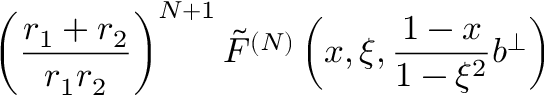<formula> <loc_0><loc_0><loc_500><loc_500>\left ( \frac { r _ { 1 } + r _ { 2 } } { r _ { 1 } r _ { 2 } } \right ) ^ { N + 1 } \tilde { F } ^ { ( N ) } \left ( x , \xi , \frac { 1 - x } { 1 - \xi ^ { 2 } } b ^ { \perp } \right )</formula> 